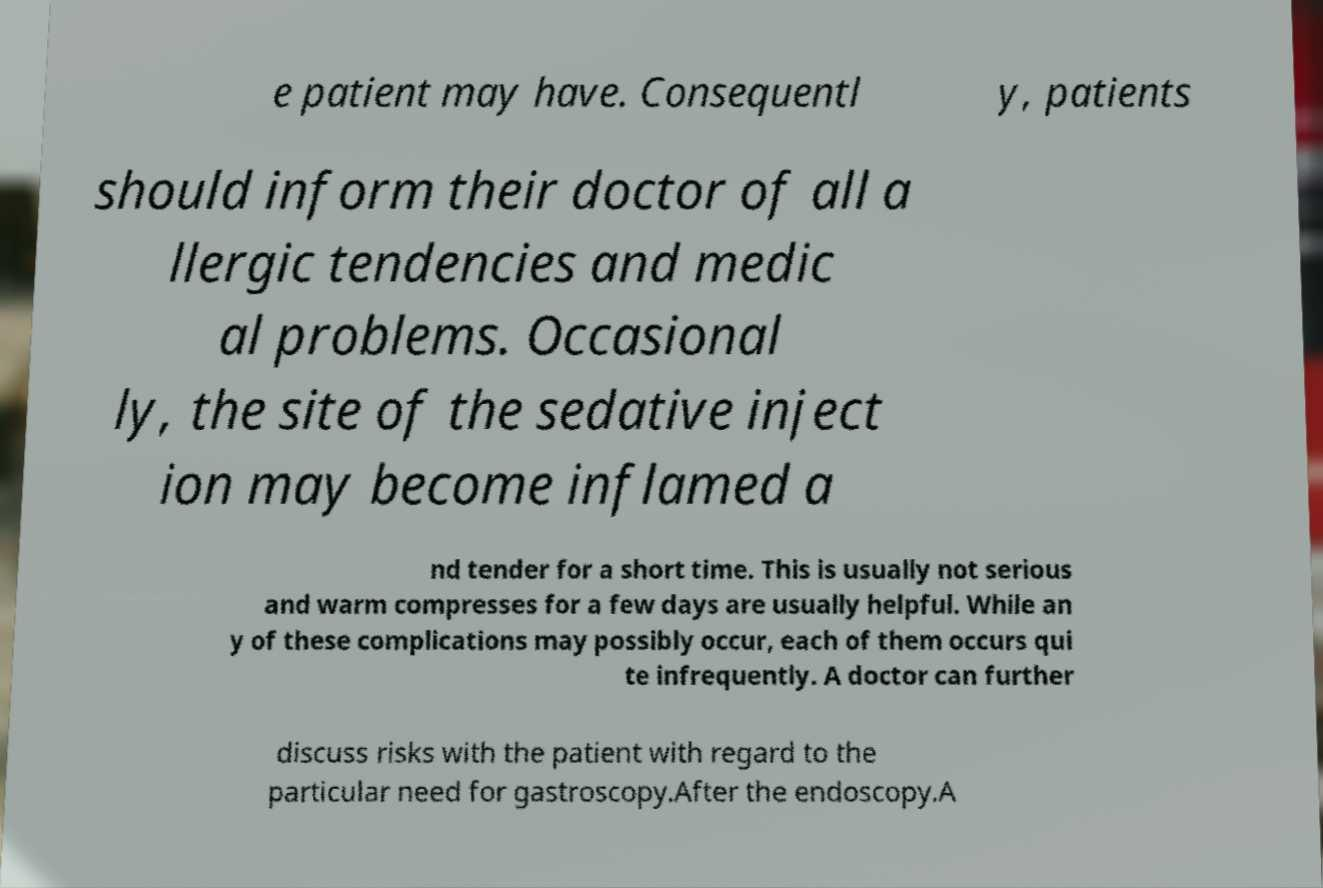Please read and relay the text visible in this image. What does it say? e patient may have. Consequentl y, patients should inform their doctor of all a llergic tendencies and medic al problems. Occasional ly, the site of the sedative inject ion may become inflamed a nd tender for a short time. This is usually not serious and warm compresses for a few days are usually helpful. While an y of these complications may possibly occur, each of them occurs qui te infrequently. A doctor can further discuss risks with the patient with regard to the particular need for gastroscopy.After the endoscopy.A 